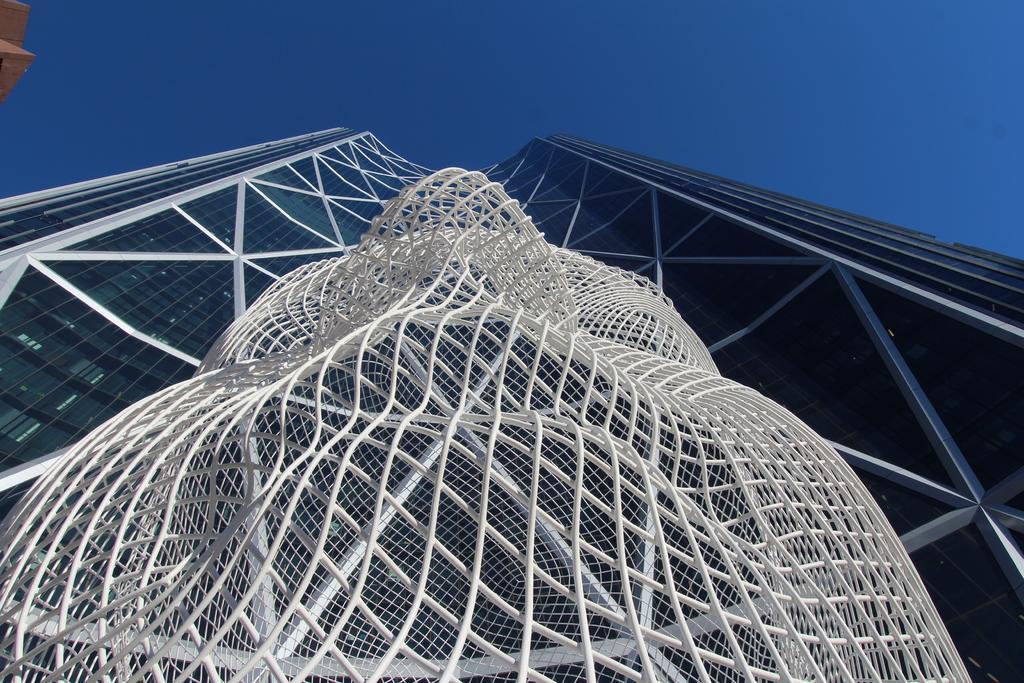Please provide a concise description of this image. In this picture I can see a building and a architecture and I can see blue sky. 